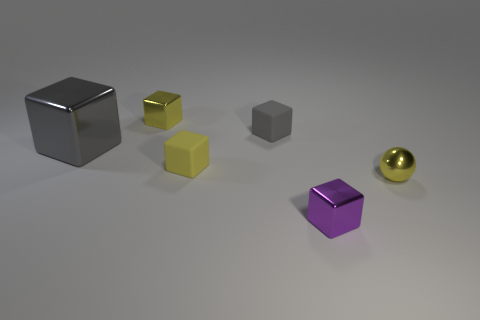Subtract 1 blocks. How many blocks are left? 4 Subtract all purple cubes. How many cubes are left? 4 Subtract all gray matte blocks. How many blocks are left? 4 Subtract all brown cubes. Subtract all purple balls. How many cubes are left? 5 Add 1 small purple cubes. How many objects exist? 7 Subtract all cubes. How many objects are left? 1 Add 1 cubes. How many cubes are left? 6 Add 5 small gray things. How many small gray things exist? 6 Subtract 0 gray spheres. How many objects are left? 6 Subtract all small gray things. Subtract all large gray cubes. How many objects are left? 4 